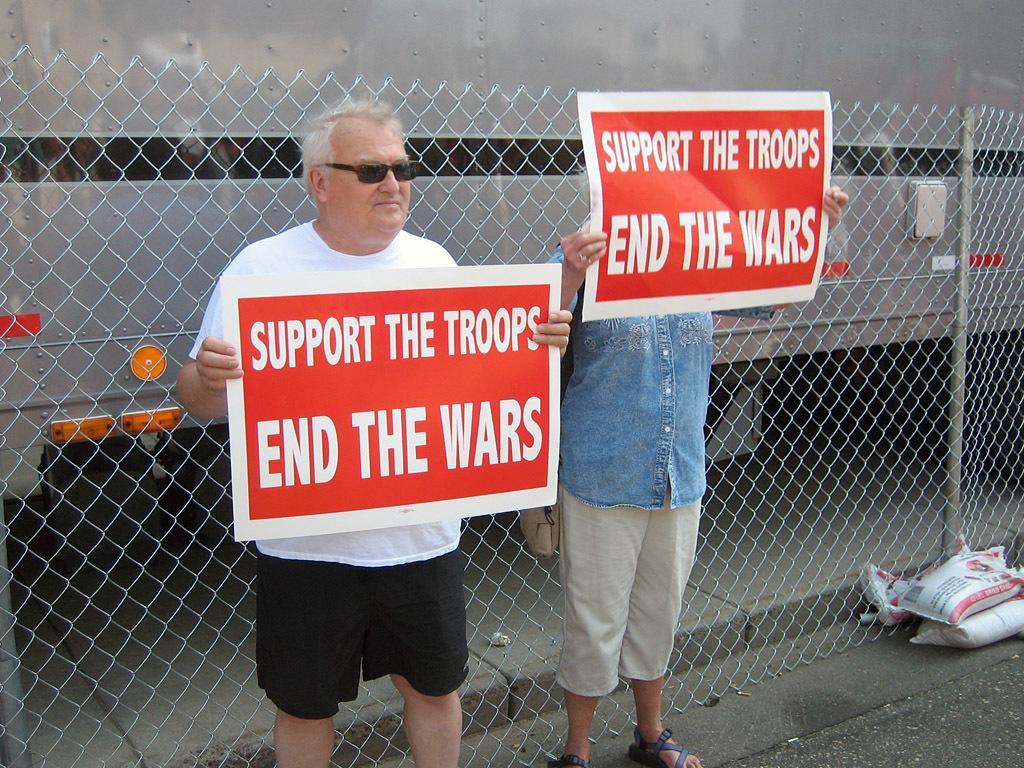In one or two sentences, can you explain what this image depicts? In the image we can see there are two people standing, wearing clothes and this person is wearing goggles. This is the posters, fence and a footpath. There is an object and a pole. 